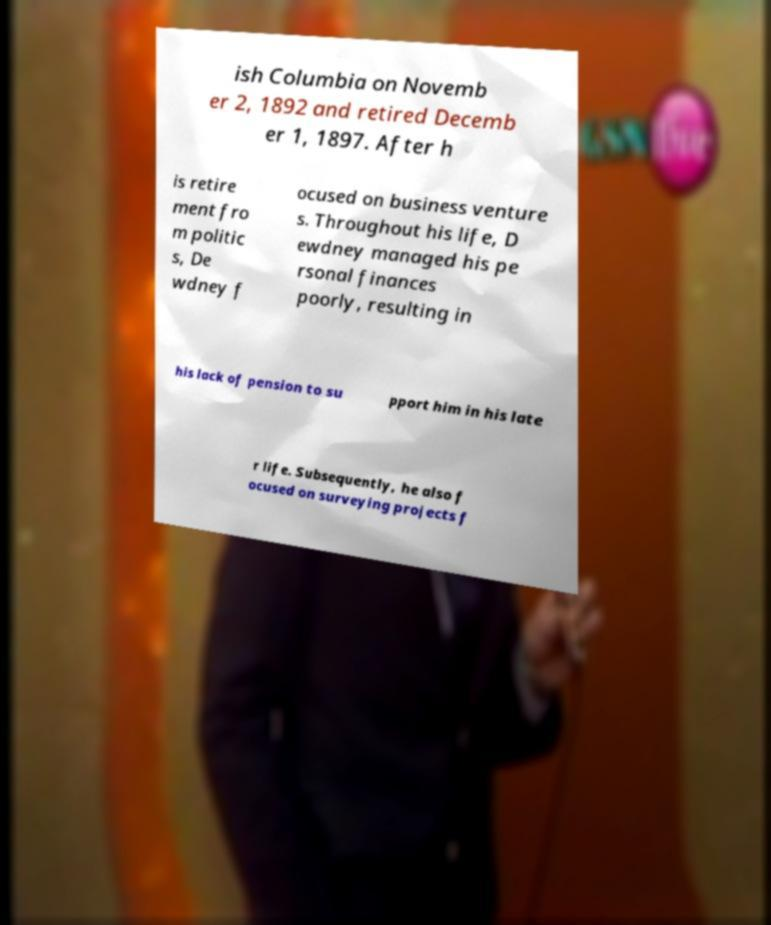What messages or text are displayed in this image? I need them in a readable, typed format. ish Columbia on Novemb er 2, 1892 and retired Decemb er 1, 1897. After h is retire ment fro m politic s, De wdney f ocused on business venture s. Throughout his life, D ewdney managed his pe rsonal finances poorly, resulting in his lack of pension to su pport him in his late r life. Subsequently, he also f ocused on surveying projects f 